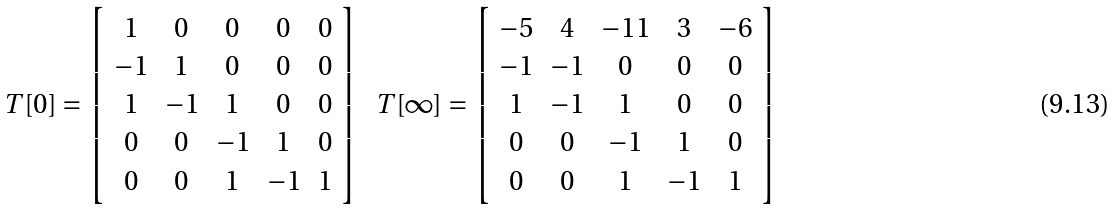<formula> <loc_0><loc_0><loc_500><loc_500>\begin{array} { c c c } { { T [ 0 ] = \left [ \begin{array} { c c c c c } { 1 } & { 0 } & { 0 } & { 0 } & { 0 } \\ { - 1 } & { 1 } & { 0 } & { 0 } & { 0 } \\ { 1 } & { - 1 } & { 1 } & { 0 } & { 0 } \\ { 0 } & { 0 } & { - 1 } & { 1 } & { 0 } \\ { 0 } & { 0 } & { 1 } & { - 1 } & { 1 } \end{array} \right ] } } & { { T [ \infty ] = \left [ \begin{array} { c c c c c } { - 5 } & { 4 } & { - 1 1 } & { 3 } & { - 6 } \\ { - 1 } & { - 1 } & { 0 } & { 0 } & { 0 } \\ { 1 } & { - 1 } & { 1 } & { 0 } & { 0 } \\ { 0 } & { 0 } & { - 1 } & { 1 } & { 0 } \\ { 0 } & { 0 } & { 1 } & { - 1 } & { 1 } \end{array} \right ] } } \end{array}</formula> 